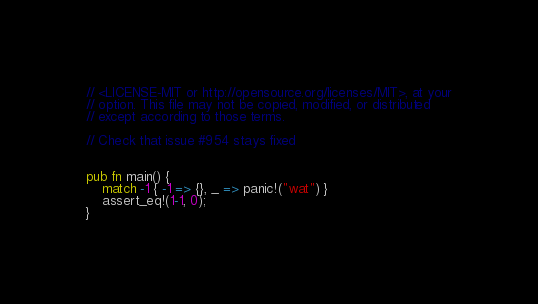Convert code to text. <code><loc_0><loc_0><loc_500><loc_500><_Rust_>// <LICENSE-MIT or http://opensource.org/licenses/MIT>, at your
// option. This file may not be copied, modified, or distributed
// except according to those terms.

// Check that issue #954 stays fixed


pub fn main() {
    match -1 { -1 => {}, _ => panic!("wat") }
    assert_eq!(1-1, 0);
}
</code> 